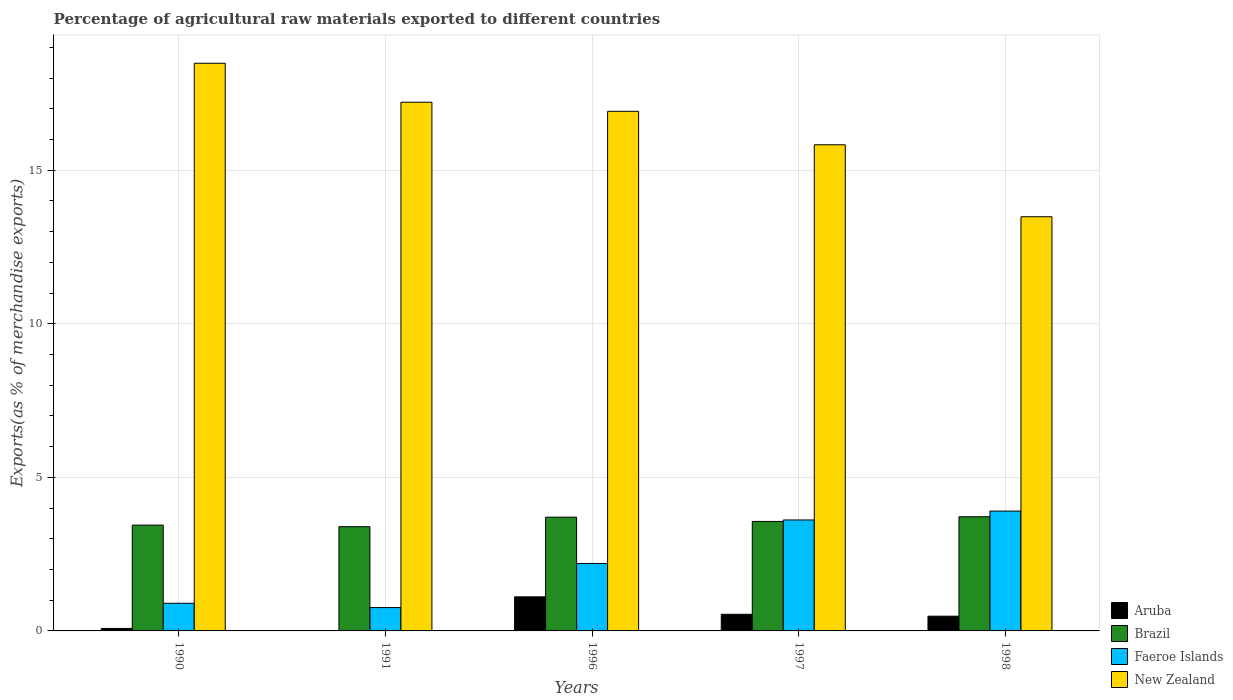Are the number of bars on each tick of the X-axis equal?
Your response must be concise. Yes. How many bars are there on the 4th tick from the left?
Provide a short and direct response. 4. What is the label of the 2nd group of bars from the left?
Provide a succinct answer. 1991. In how many cases, is the number of bars for a given year not equal to the number of legend labels?
Provide a succinct answer. 0. What is the percentage of exports to different countries in New Zealand in 1998?
Your response must be concise. 13.48. Across all years, what is the maximum percentage of exports to different countries in Aruba?
Keep it short and to the point. 1.11. Across all years, what is the minimum percentage of exports to different countries in Brazil?
Give a very brief answer. 3.39. In which year was the percentage of exports to different countries in Aruba minimum?
Give a very brief answer. 1991. What is the total percentage of exports to different countries in New Zealand in the graph?
Your response must be concise. 81.92. What is the difference between the percentage of exports to different countries in New Zealand in 1991 and that in 1998?
Offer a very short reply. 3.73. What is the difference between the percentage of exports to different countries in Faeroe Islands in 1997 and the percentage of exports to different countries in Brazil in 1991?
Make the answer very short. 0.22. What is the average percentage of exports to different countries in Faeroe Islands per year?
Provide a succinct answer. 2.27. In the year 1997, what is the difference between the percentage of exports to different countries in Aruba and percentage of exports to different countries in Brazil?
Provide a succinct answer. -3.02. In how many years, is the percentage of exports to different countries in New Zealand greater than 14 %?
Offer a very short reply. 4. What is the ratio of the percentage of exports to different countries in Aruba in 1991 to that in 1998?
Offer a terse response. 0.01. What is the difference between the highest and the second highest percentage of exports to different countries in Brazil?
Make the answer very short. 0.01. What is the difference between the highest and the lowest percentage of exports to different countries in New Zealand?
Give a very brief answer. 5. In how many years, is the percentage of exports to different countries in Brazil greater than the average percentage of exports to different countries in Brazil taken over all years?
Make the answer very short. 2. Is the sum of the percentage of exports to different countries in Faeroe Islands in 1991 and 1996 greater than the maximum percentage of exports to different countries in Aruba across all years?
Keep it short and to the point. Yes. Is it the case that in every year, the sum of the percentage of exports to different countries in Brazil and percentage of exports to different countries in Aruba is greater than the sum of percentage of exports to different countries in Faeroe Islands and percentage of exports to different countries in New Zealand?
Make the answer very short. No. What does the 2nd bar from the left in 1997 represents?
Offer a terse response. Brazil. What does the 4th bar from the right in 1991 represents?
Make the answer very short. Aruba. How many bars are there?
Your response must be concise. 20. Are all the bars in the graph horizontal?
Your response must be concise. No. How many years are there in the graph?
Keep it short and to the point. 5. Are the values on the major ticks of Y-axis written in scientific E-notation?
Keep it short and to the point. No. Does the graph contain any zero values?
Offer a very short reply. No. Where does the legend appear in the graph?
Provide a short and direct response. Bottom right. How many legend labels are there?
Offer a terse response. 4. What is the title of the graph?
Give a very brief answer. Percentage of agricultural raw materials exported to different countries. What is the label or title of the X-axis?
Offer a terse response. Years. What is the label or title of the Y-axis?
Make the answer very short. Exports(as % of merchandise exports). What is the Exports(as % of merchandise exports) in Aruba in 1990?
Your response must be concise. 0.08. What is the Exports(as % of merchandise exports) of Brazil in 1990?
Your answer should be compact. 3.44. What is the Exports(as % of merchandise exports) of Faeroe Islands in 1990?
Your answer should be compact. 0.9. What is the Exports(as % of merchandise exports) of New Zealand in 1990?
Provide a short and direct response. 18.48. What is the Exports(as % of merchandise exports) of Aruba in 1991?
Provide a succinct answer. 0. What is the Exports(as % of merchandise exports) in Brazil in 1991?
Provide a short and direct response. 3.39. What is the Exports(as % of merchandise exports) of Faeroe Islands in 1991?
Provide a short and direct response. 0.76. What is the Exports(as % of merchandise exports) in New Zealand in 1991?
Keep it short and to the point. 17.21. What is the Exports(as % of merchandise exports) in Aruba in 1996?
Ensure brevity in your answer.  1.11. What is the Exports(as % of merchandise exports) of Brazil in 1996?
Offer a terse response. 3.7. What is the Exports(as % of merchandise exports) of Faeroe Islands in 1996?
Offer a very short reply. 2.2. What is the Exports(as % of merchandise exports) in New Zealand in 1996?
Provide a short and direct response. 16.92. What is the Exports(as % of merchandise exports) in Aruba in 1997?
Your response must be concise. 0.54. What is the Exports(as % of merchandise exports) in Brazil in 1997?
Keep it short and to the point. 3.56. What is the Exports(as % of merchandise exports) of Faeroe Islands in 1997?
Make the answer very short. 3.61. What is the Exports(as % of merchandise exports) of New Zealand in 1997?
Give a very brief answer. 15.83. What is the Exports(as % of merchandise exports) in Aruba in 1998?
Your answer should be compact. 0.48. What is the Exports(as % of merchandise exports) in Brazil in 1998?
Your answer should be compact. 3.72. What is the Exports(as % of merchandise exports) of Faeroe Islands in 1998?
Keep it short and to the point. 3.9. What is the Exports(as % of merchandise exports) of New Zealand in 1998?
Provide a succinct answer. 13.48. Across all years, what is the maximum Exports(as % of merchandise exports) of Aruba?
Your answer should be compact. 1.11. Across all years, what is the maximum Exports(as % of merchandise exports) of Brazil?
Provide a succinct answer. 3.72. Across all years, what is the maximum Exports(as % of merchandise exports) in Faeroe Islands?
Make the answer very short. 3.9. Across all years, what is the maximum Exports(as % of merchandise exports) in New Zealand?
Your answer should be compact. 18.48. Across all years, what is the minimum Exports(as % of merchandise exports) in Aruba?
Offer a very short reply. 0. Across all years, what is the minimum Exports(as % of merchandise exports) in Brazil?
Offer a terse response. 3.39. Across all years, what is the minimum Exports(as % of merchandise exports) in Faeroe Islands?
Your answer should be very brief. 0.76. Across all years, what is the minimum Exports(as % of merchandise exports) in New Zealand?
Your response must be concise. 13.48. What is the total Exports(as % of merchandise exports) in Aruba in the graph?
Keep it short and to the point. 2.22. What is the total Exports(as % of merchandise exports) in Brazil in the graph?
Your answer should be compact. 17.82. What is the total Exports(as % of merchandise exports) of Faeroe Islands in the graph?
Ensure brevity in your answer.  11.37. What is the total Exports(as % of merchandise exports) in New Zealand in the graph?
Offer a terse response. 81.92. What is the difference between the Exports(as % of merchandise exports) of Aruba in 1990 and that in 1991?
Give a very brief answer. 0.08. What is the difference between the Exports(as % of merchandise exports) of Brazil in 1990 and that in 1991?
Offer a very short reply. 0.05. What is the difference between the Exports(as % of merchandise exports) in Faeroe Islands in 1990 and that in 1991?
Your response must be concise. 0.14. What is the difference between the Exports(as % of merchandise exports) of New Zealand in 1990 and that in 1991?
Your answer should be very brief. 1.27. What is the difference between the Exports(as % of merchandise exports) of Aruba in 1990 and that in 1996?
Your response must be concise. -1.03. What is the difference between the Exports(as % of merchandise exports) of Brazil in 1990 and that in 1996?
Give a very brief answer. -0.26. What is the difference between the Exports(as % of merchandise exports) of Faeroe Islands in 1990 and that in 1996?
Keep it short and to the point. -1.3. What is the difference between the Exports(as % of merchandise exports) in New Zealand in 1990 and that in 1996?
Ensure brevity in your answer.  1.56. What is the difference between the Exports(as % of merchandise exports) in Aruba in 1990 and that in 1997?
Your response must be concise. -0.46. What is the difference between the Exports(as % of merchandise exports) of Brazil in 1990 and that in 1997?
Your response must be concise. -0.12. What is the difference between the Exports(as % of merchandise exports) of Faeroe Islands in 1990 and that in 1997?
Give a very brief answer. -2.71. What is the difference between the Exports(as % of merchandise exports) in New Zealand in 1990 and that in 1997?
Make the answer very short. 2.65. What is the difference between the Exports(as % of merchandise exports) of Aruba in 1990 and that in 1998?
Give a very brief answer. -0.4. What is the difference between the Exports(as % of merchandise exports) in Brazil in 1990 and that in 1998?
Your response must be concise. -0.27. What is the difference between the Exports(as % of merchandise exports) in Faeroe Islands in 1990 and that in 1998?
Provide a short and direct response. -3. What is the difference between the Exports(as % of merchandise exports) in New Zealand in 1990 and that in 1998?
Ensure brevity in your answer.  5. What is the difference between the Exports(as % of merchandise exports) in Aruba in 1991 and that in 1996?
Make the answer very short. -1.11. What is the difference between the Exports(as % of merchandise exports) of Brazil in 1991 and that in 1996?
Provide a short and direct response. -0.31. What is the difference between the Exports(as % of merchandise exports) of Faeroe Islands in 1991 and that in 1996?
Give a very brief answer. -1.44. What is the difference between the Exports(as % of merchandise exports) in New Zealand in 1991 and that in 1996?
Ensure brevity in your answer.  0.3. What is the difference between the Exports(as % of merchandise exports) of Aruba in 1991 and that in 1997?
Ensure brevity in your answer.  -0.54. What is the difference between the Exports(as % of merchandise exports) in Brazil in 1991 and that in 1997?
Make the answer very short. -0.17. What is the difference between the Exports(as % of merchandise exports) of Faeroe Islands in 1991 and that in 1997?
Your response must be concise. -2.85. What is the difference between the Exports(as % of merchandise exports) of New Zealand in 1991 and that in 1997?
Your response must be concise. 1.39. What is the difference between the Exports(as % of merchandise exports) in Aruba in 1991 and that in 1998?
Provide a short and direct response. -0.48. What is the difference between the Exports(as % of merchandise exports) in Brazil in 1991 and that in 1998?
Offer a terse response. -0.32. What is the difference between the Exports(as % of merchandise exports) in Faeroe Islands in 1991 and that in 1998?
Ensure brevity in your answer.  -3.14. What is the difference between the Exports(as % of merchandise exports) in New Zealand in 1991 and that in 1998?
Provide a short and direct response. 3.73. What is the difference between the Exports(as % of merchandise exports) of Aruba in 1996 and that in 1997?
Ensure brevity in your answer.  0.57. What is the difference between the Exports(as % of merchandise exports) of Brazil in 1996 and that in 1997?
Ensure brevity in your answer.  0.14. What is the difference between the Exports(as % of merchandise exports) of Faeroe Islands in 1996 and that in 1997?
Your response must be concise. -1.42. What is the difference between the Exports(as % of merchandise exports) in New Zealand in 1996 and that in 1997?
Ensure brevity in your answer.  1.09. What is the difference between the Exports(as % of merchandise exports) in Aruba in 1996 and that in 1998?
Your answer should be very brief. 0.63. What is the difference between the Exports(as % of merchandise exports) of Brazil in 1996 and that in 1998?
Provide a short and direct response. -0.01. What is the difference between the Exports(as % of merchandise exports) of Faeroe Islands in 1996 and that in 1998?
Make the answer very short. -1.71. What is the difference between the Exports(as % of merchandise exports) of New Zealand in 1996 and that in 1998?
Make the answer very short. 3.43. What is the difference between the Exports(as % of merchandise exports) of Aruba in 1997 and that in 1998?
Your response must be concise. 0.06. What is the difference between the Exports(as % of merchandise exports) of Brazil in 1997 and that in 1998?
Your response must be concise. -0.15. What is the difference between the Exports(as % of merchandise exports) in Faeroe Islands in 1997 and that in 1998?
Offer a terse response. -0.29. What is the difference between the Exports(as % of merchandise exports) in New Zealand in 1997 and that in 1998?
Your response must be concise. 2.34. What is the difference between the Exports(as % of merchandise exports) of Aruba in 1990 and the Exports(as % of merchandise exports) of Brazil in 1991?
Provide a succinct answer. -3.31. What is the difference between the Exports(as % of merchandise exports) of Aruba in 1990 and the Exports(as % of merchandise exports) of Faeroe Islands in 1991?
Provide a short and direct response. -0.68. What is the difference between the Exports(as % of merchandise exports) of Aruba in 1990 and the Exports(as % of merchandise exports) of New Zealand in 1991?
Keep it short and to the point. -17.13. What is the difference between the Exports(as % of merchandise exports) in Brazil in 1990 and the Exports(as % of merchandise exports) in Faeroe Islands in 1991?
Offer a very short reply. 2.68. What is the difference between the Exports(as % of merchandise exports) of Brazil in 1990 and the Exports(as % of merchandise exports) of New Zealand in 1991?
Provide a short and direct response. -13.77. What is the difference between the Exports(as % of merchandise exports) in Faeroe Islands in 1990 and the Exports(as % of merchandise exports) in New Zealand in 1991?
Offer a terse response. -16.31. What is the difference between the Exports(as % of merchandise exports) in Aruba in 1990 and the Exports(as % of merchandise exports) in Brazil in 1996?
Your answer should be compact. -3.62. What is the difference between the Exports(as % of merchandise exports) in Aruba in 1990 and the Exports(as % of merchandise exports) in Faeroe Islands in 1996?
Provide a short and direct response. -2.11. What is the difference between the Exports(as % of merchandise exports) of Aruba in 1990 and the Exports(as % of merchandise exports) of New Zealand in 1996?
Your response must be concise. -16.84. What is the difference between the Exports(as % of merchandise exports) of Brazil in 1990 and the Exports(as % of merchandise exports) of Faeroe Islands in 1996?
Your response must be concise. 1.25. What is the difference between the Exports(as % of merchandise exports) in Brazil in 1990 and the Exports(as % of merchandise exports) in New Zealand in 1996?
Keep it short and to the point. -13.47. What is the difference between the Exports(as % of merchandise exports) of Faeroe Islands in 1990 and the Exports(as % of merchandise exports) of New Zealand in 1996?
Keep it short and to the point. -16.02. What is the difference between the Exports(as % of merchandise exports) of Aruba in 1990 and the Exports(as % of merchandise exports) of Brazil in 1997?
Your answer should be very brief. -3.48. What is the difference between the Exports(as % of merchandise exports) of Aruba in 1990 and the Exports(as % of merchandise exports) of Faeroe Islands in 1997?
Offer a very short reply. -3.53. What is the difference between the Exports(as % of merchandise exports) of Aruba in 1990 and the Exports(as % of merchandise exports) of New Zealand in 1997?
Provide a short and direct response. -15.75. What is the difference between the Exports(as % of merchandise exports) in Brazil in 1990 and the Exports(as % of merchandise exports) in Faeroe Islands in 1997?
Give a very brief answer. -0.17. What is the difference between the Exports(as % of merchandise exports) in Brazil in 1990 and the Exports(as % of merchandise exports) in New Zealand in 1997?
Ensure brevity in your answer.  -12.38. What is the difference between the Exports(as % of merchandise exports) in Faeroe Islands in 1990 and the Exports(as % of merchandise exports) in New Zealand in 1997?
Your answer should be compact. -14.93. What is the difference between the Exports(as % of merchandise exports) of Aruba in 1990 and the Exports(as % of merchandise exports) of Brazil in 1998?
Your answer should be compact. -3.64. What is the difference between the Exports(as % of merchandise exports) in Aruba in 1990 and the Exports(as % of merchandise exports) in Faeroe Islands in 1998?
Offer a terse response. -3.82. What is the difference between the Exports(as % of merchandise exports) in Aruba in 1990 and the Exports(as % of merchandise exports) in New Zealand in 1998?
Offer a terse response. -13.4. What is the difference between the Exports(as % of merchandise exports) of Brazil in 1990 and the Exports(as % of merchandise exports) of Faeroe Islands in 1998?
Make the answer very short. -0.46. What is the difference between the Exports(as % of merchandise exports) of Brazil in 1990 and the Exports(as % of merchandise exports) of New Zealand in 1998?
Your response must be concise. -10.04. What is the difference between the Exports(as % of merchandise exports) in Faeroe Islands in 1990 and the Exports(as % of merchandise exports) in New Zealand in 1998?
Your response must be concise. -12.58. What is the difference between the Exports(as % of merchandise exports) in Aruba in 1991 and the Exports(as % of merchandise exports) in Brazil in 1996?
Offer a very short reply. -3.7. What is the difference between the Exports(as % of merchandise exports) of Aruba in 1991 and the Exports(as % of merchandise exports) of Faeroe Islands in 1996?
Offer a very short reply. -2.19. What is the difference between the Exports(as % of merchandise exports) of Aruba in 1991 and the Exports(as % of merchandise exports) of New Zealand in 1996?
Keep it short and to the point. -16.91. What is the difference between the Exports(as % of merchandise exports) in Brazil in 1991 and the Exports(as % of merchandise exports) in Faeroe Islands in 1996?
Your answer should be very brief. 1.2. What is the difference between the Exports(as % of merchandise exports) in Brazil in 1991 and the Exports(as % of merchandise exports) in New Zealand in 1996?
Offer a terse response. -13.52. What is the difference between the Exports(as % of merchandise exports) in Faeroe Islands in 1991 and the Exports(as % of merchandise exports) in New Zealand in 1996?
Provide a succinct answer. -16.16. What is the difference between the Exports(as % of merchandise exports) in Aruba in 1991 and the Exports(as % of merchandise exports) in Brazil in 1997?
Your answer should be compact. -3.56. What is the difference between the Exports(as % of merchandise exports) of Aruba in 1991 and the Exports(as % of merchandise exports) of Faeroe Islands in 1997?
Your response must be concise. -3.61. What is the difference between the Exports(as % of merchandise exports) of Aruba in 1991 and the Exports(as % of merchandise exports) of New Zealand in 1997?
Your answer should be compact. -15.82. What is the difference between the Exports(as % of merchandise exports) in Brazil in 1991 and the Exports(as % of merchandise exports) in Faeroe Islands in 1997?
Offer a very short reply. -0.22. What is the difference between the Exports(as % of merchandise exports) in Brazil in 1991 and the Exports(as % of merchandise exports) in New Zealand in 1997?
Provide a short and direct response. -12.43. What is the difference between the Exports(as % of merchandise exports) of Faeroe Islands in 1991 and the Exports(as % of merchandise exports) of New Zealand in 1997?
Offer a very short reply. -15.07. What is the difference between the Exports(as % of merchandise exports) in Aruba in 1991 and the Exports(as % of merchandise exports) in Brazil in 1998?
Make the answer very short. -3.71. What is the difference between the Exports(as % of merchandise exports) in Aruba in 1991 and the Exports(as % of merchandise exports) in Faeroe Islands in 1998?
Provide a short and direct response. -3.9. What is the difference between the Exports(as % of merchandise exports) in Aruba in 1991 and the Exports(as % of merchandise exports) in New Zealand in 1998?
Your answer should be compact. -13.48. What is the difference between the Exports(as % of merchandise exports) in Brazil in 1991 and the Exports(as % of merchandise exports) in Faeroe Islands in 1998?
Offer a terse response. -0.51. What is the difference between the Exports(as % of merchandise exports) of Brazil in 1991 and the Exports(as % of merchandise exports) of New Zealand in 1998?
Provide a succinct answer. -10.09. What is the difference between the Exports(as % of merchandise exports) of Faeroe Islands in 1991 and the Exports(as % of merchandise exports) of New Zealand in 1998?
Keep it short and to the point. -12.72. What is the difference between the Exports(as % of merchandise exports) in Aruba in 1996 and the Exports(as % of merchandise exports) in Brazil in 1997?
Make the answer very short. -2.45. What is the difference between the Exports(as % of merchandise exports) of Aruba in 1996 and the Exports(as % of merchandise exports) of Faeroe Islands in 1997?
Offer a terse response. -2.5. What is the difference between the Exports(as % of merchandise exports) in Aruba in 1996 and the Exports(as % of merchandise exports) in New Zealand in 1997?
Keep it short and to the point. -14.72. What is the difference between the Exports(as % of merchandise exports) in Brazil in 1996 and the Exports(as % of merchandise exports) in Faeroe Islands in 1997?
Give a very brief answer. 0.09. What is the difference between the Exports(as % of merchandise exports) in Brazil in 1996 and the Exports(as % of merchandise exports) in New Zealand in 1997?
Provide a succinct answer. -12.12. What is the difference between the Exports(as % of merchandise exports) of Faeroe Islands in 1996 and the Exports(as % of merchandise exports) of New Zealand in 1997?
Make the answer very short. -13.63. What is the difference between the Exports(as % of merchandise exports) in Aruba in 1996 and the Exports(as % of merchandise exports) in Brazil in 1998?
Ensure brevity in your answer.  -2.61. What is the difference between the Exports(as % of merchandise exports) in Aruba in 1996 and the Exports(as % of merchandise exports) in Faeroe Islands in 1998?
Give a very brief answer. -2.79. What is the difference between the Exports(as % of merchandise exports) in Aruba in 1996 and the Exports(as % of merchandise exports) in New Zealand in 1998?
Keep it short and to the point. -12.37. What is the difference between the Exports(as % of merchandise exports) of Brazil in 1996 and the Exports(as % of merchandise exports) of Faeroe Islands in 1998?
Offer a very short reply. -0.2. What is the difference between the Exports(as % of merchandise exports) of Brazil in 1996 and the Exports(as % of merchandise exports) of New Zealand in 1998?
Provide a short and direct response. -9.78. What is the difference between the Exports(as % of merchandise exports) of Faeroe Islands in 1996 and the Exports(as % of merchandise exports) of New Zealand in 1998?
Offer a very short reply. -11.29. What is the difference between the Exports(as % of merchandise exports) in Aruba in 1997 and the Exports(as % of merchandise exports) in Brazil in 1998?
Offer a very short reply. -3.18. What is the difference between the Exports(as % of merchandise exports) of Aruba in 1997 and the Exports(as % of merchandise exports) of Faeroe Islands in 1998?
Provide a succinct answer. -3.36. What is the difference between the Exports(as % of merchandise exports) of Aruba in 1997 and the Exports(as % of merchandise exports) of New Zealand in 1998?
Your answer should be compact. -12.94. What is the difference between the Exports(as % of merchandise exports) in Brazil in 1997 and the Exports(as % of merchandise exports) in Faeroe Islands in 1998?
Offer a very short reply. -0.34. What is the difference between the Exports(as % of merchandise exports) of Brazil in 1997 and the Exports(as % of merchandise exports) of New Zealand in 1998?
Provide a short and direct response. -9.92. What is the difference between the Exports(as % of merchandise exports) in Faeroe Islands in 1997 and the Exports(as % of merchandise exports) in New Zealand in 1998?
Your answer should be compact. -9.87. What is the average Exports(as % of merchandise exports) of Aruba per year?
Offer a terse response. 0.44. What is the average Exports(as % of merchandise exports) of Brazil per year?
Ensure brevity in your answer.  3.56. What is the average Exports(as % of merchandise exports) of Faeroe Islands per year?
Provide a short and direct response. 2.27. What is the average Exports(as % of merchandise exports) of New Zealand per year?
Your answer should be very brief. 16.38. In the year 1990, what is the difference between the Exports(as % of merchandise exports) in Aruba and Exports(as % of merchandise exports) in Brazil?
Ensure brevity in your answer.  -3.36. In the year 1990, what is the difference between the Exports(as % of merchandise exports) of Aruba and Exports(as % of merchandise exports) of Faeroe Islands?
Offer a very short reply. -0.82. In the year 1990, what is the difference between the Exports(as % of merchandise exports) in Aruba and Exports(as % of merchandise exports) in New Zealand?
Your answer should be very brief. -18.4. In the year 1990, what is the difference between the Exports(as % of merchandise exports) of Brazil and Exports(as % of merchandise exports) of Faeroe Islands?
Your response must be concise. 2.54. In the year 1990, what is the difference between the Exports(as % of merchandise exports) of Brazil and Exports(as % of merchandise exports) of New Zealand?
Your response must be concise. -15.04. In the year 1990, what is the difference between the Exports(as % of merchandise exports) in Faeroe Islands and Exports(as % of merchandise exports) in New Zealand?
Your answer should be very brief. -17.58. In the year 1991, what is the difference between the Exports(as % of merchandise exports) in Aruba and Exports(as % of merchandise exports) in Brazil?
Provide a succinct answer. -3.39. In the year 1991, what is the difference between the Exports(as % of merchandise exports) in Aruba and Exports(as % of merchandise exports) in Faeroe Islands?
Your answer should be very brief. -0.76. In the year 1991, what is the difference between the Exports(as % of merchandise exports) of Aruba and Exports(as % of merchandise exports) of New Zealand?
Provide a short and direct response. -17.21. In the year 1991, what is the difference between the Exports(as % of merchandise exports) of Brazil and Exports(as % of merchandise exports) of Faeroe Islands?
Make the answer very short. 2.63. In the year 1991, what is the difference between the Exports(as % of merchandise exports) of Brazil and Exports(as % of merchandise exports) of New Zealand?
Give a very brief answer. -13.82. In the year 1991, what is the difference between the Exports(as % of merchandise exports) of Faeroe Islands and Exports(as % of merchandise exports) of New Zealand?
Make the answer very short. -16.45. In the year 1996, what is the difference between the Exports(as % of merchandise exports) of Aruba and Exports(as % of merchandise exports) of Brazil?
Offer a terse response. -2.59. In the year 1996, what is the difference between the Exports(as % of merchandise exports) of Aruba and Exports(as % of merchandise exports) of Faeroe Islands?
Provide a succinct answer. -1.09. In the year 1996, what is the difference between the Exports(as % of merchandise exports) in Aruba and Exports(as % of merchandise exports) in New Zealand?
Give a very brief answer. -15.81. In the year 1996, what is the difference between the Exports(as % of merchandise exports) of Brazil and Exports(as % of merchandise exports) of Faeroe Islands?
Offer a terse response. 1.51. In the year 1996, what is the difference between the Exports(as % of merchandise exports) in Brazil and Exports(as % of merchandise exports) in New Zealand?
Ensure brevity in your answer.  -13.21. In the year 1996, what is the difference between the Exports(as % of merchandise exports) in Faeroe Islands and Exports(as % of merchandise exports) in New Zealand?
Provide a succinct answer. -14.72. In the year 1997, what is the difference between the Exports(as % of merchandise exports) of Aruba and Exports(as % of merchandise exports) of Brazil?
Give a very brief answer. -3.02. In the year 1997, what is the difference between the Exports(as % of merchandise exports) of Aruba and Exports(as % of merchandise exports) of Faeroe Islands?
Your response must be concise. -3.07. In the year 1997, what is the difference between the Exports(as % of merchandise exports) of Aruba and Exports(as % of merchandise exports) of New Zealand?
Your answer should be compact. -15.28. In the year 1997, what is the difference between the Exports(as % of merchandise exports) of Brazil and Exports(as % of merchandise exports) of Faeroe Islands?
Ensure brevity in your answer.  -0.05. In the year 1997, what is the difference between the Exports(as % of merchandise exports) in Brazil and Exports(as % of merchandise exports) in New Zealand?
Give a very brief answer. -12.26. In the year 1997, what is the difference between the Exports(as % of merchandise exports) in Faeroe Islands and Exports(as % of merchandise exports) in New Zealand?
Ensure brevity in your answer.  -12.21. In the year 1998, what is the difference between the Exports(as % of merchandise exports) of Aruba and Exports(as % of merchandise exports) of Brazil?
Your answer should be very brief. -3.24. In the year 1998, what is the difference between the Exports(as % of merchandise exports) of Aruba and Exports(as % of merchandise exports) of Faeroe Islands?
Make the answer very short. -3.42. In the year 1998, what is the difference between the Exports(as % of merchandise exports) of Aruba and Exports(as % of merchandise exports) of New Zealand?
Make the answer very short. -13. In the year 1998, what is the difference between the Exports(as % of merchandise exports) in Brazil and Exports(as % of merchandise exports) in Faeroe Islands?
Ensure brevity in your answer.  -0.19. In the year 1998, what is the difference between the Exports(as % of merchandise exports) in Brazil and Exports(as % of merchandise exports) in New Zealand?
Give a very brief answer. -9.77. In the year 1998, what is the difference between the Exports(as % of merchandise exports) of Faeroe Islands and Exports(as % of merchandise exports) of New Zealand?
Offer a terse response. -9.58. What is the ratio of the Exports(as % of merchandise exports) of Aruba in 1990 to that in 1991?
Provide a short and direct response. 18.9. What is the ratio of the Exports(as % of merchandise exports) of Brazil in 1990 to that in 1991?
Provide a succinct answer. 1.01. What is the ratio of the Exports(as % of merchandise exports) of Faeroe Islands in 1990 to that in 1991?
Give a very brief answer. 1.18. What is the ratio of the Exports(as % of merchandise exports) in New Zealand in 1990 to that in 1991?
Your answer should be very brief. 1.07. What is the ratio of the Exports(as % of merchandise exports) in Aruba in 1990 to that in 1996?
Your answer should be compact. 0.07. What is the ratio of the Exports(as % of merchandise exports) of Faeroe Islands in 1990 to that in 1996?
Give a very brief answer. 0.41. What is the ratio of the Exports(as % of merchandise exports) in New Zealand in 1990 to that in 1996?
Ensure brevity in your answer.  1.09. What is the ratio of the Exports(as % of merchandise exports) in Aruba in 1990 to that in 1997?
Provide a succinct answer. 0.15. What is the ratio of the Exports(as % of merchandise exports) in Brazil in 1990 to that in 1997?
Keep it short and to the point. 0.97. What is the ratio of the Exports(as % of merchandise exports) in Faeroe Islands in 1990 to that in 1997?
Give a very brief answer. 0.25. What is the ratio of the Exports(as % of merchandise exports) of New Zealand in 1990 to that in 1997?
Provide a short and direct response. 1.17. What is the ratio of the Exports(as % of merchandise exports) of Aruba in 1990 to that in 1998?
Provide a short and direct response. 0.17. What is the ratio of the Exports(as % of merchandise exports) of Brazil in 1990 to that in 1998?
Ensure brevity in your answer.  0.93. What is the ratio of the Exports(as % of merchandise exports) in Faeroe Islands in 1990 to that in 1998?
Offer a terse response. 0.23. What is the ratio of the Exports(as % of merchandise exports) of New Zealand in 1990 to that in 1998?
Offer a terse response. 1.37. What is the ratio of the Exports(as % of merchandise exports) of Aruba in 1991 to that in 1996?
Make the answer very short. 0. What is the ratio of the Exports(as % of merchandise exports) of Brazil in 1991 to that in 1996?
Ensure brevity in your answer.  0.92. What is the ratio of the Exports(as % of merchandise exports) of Faeroe Islands in 1991 to that in 1996?
Keep it short and to the point. 0.35. What is the ratio of the Exports(as % of merchandise exports) in New Zealand in 1991 to that in 1996?
Keep it short and to the point. 1.02. What is the ratio of the Exports(as % of merchandise exports) of Aruba in 1991 to that in 1997?
Offer a very short reply. 0.01. What is the ratio of the Exports(as % of merchandise exports) of Brazil in 1991 to that in 1997?
Ensure brevity in your answer.  0.95. What is the ratio of the Exports(as % of merchandise exports) in Faeroe Islands in 1991 to that in 1997?
Provide a short and direct response. 0.21. What is the ratio of the Exports(as % of merchandise exports) in New Zealand in 1991 to that in 1997?
Make the answer very short. 1.09. What is the ratio of the Exports(as % of merchandise exports) in Aruba in 1991 to that in 1998?
Your response must be concise. 0.01. What is the ratio of the Exports(as % of merchandise exports) in Brazil in 1991 to that in 1998?
Make the answer very short. 0.91. What is the ratio of the Exports(as % of merchandise exports) in Faeroe Islands in 1991 to that in 1998?
Provide a succinct answer. 0.19. What is the ratio of the Exports(as % of merchandise exports) in New Zealand in 1991 to that in 1998?
Keep it short and to the point. 1.28. What is the ratio of the Exports(as % of merchandise exports) of Aruba in 1996 to that in 1997?
Keep it short and to the point. 2.05. What is the ratio of the Exports(as % of merchandise exports) in Brazil in 1996 to that in 1997?
Provide a succinct answer. 1.04. What is the ratio of the Exports(as % of merchandise exports) in Faeroe Islands in 1996 to that in 1997?
Make the answer very short. 0.61. What is the ratio of the Exports(as % of merchandise exports) of New Zealand in 1996 to that in 1997?
Your response must be concise. 1.07. What is the ratio of the Exports(as % of merchandise exports) in Aruba in 1996 to that in 1998?
Your response must be concise. 2.31. What is the ratio of the Exports(as % of merchandise exports) of Faeroe Islands in 1996 to that in 1998?
Your response must be concise. 0.56. What is the ratio of the Exports(as % of merchandise exports) in New Zealand in 1996 to that in 1998?
Offer a terse response. 1.25. What is the ratio of the Exports(as % of merchandise exports) in Aruba in 1997 to that in 1998?
Offer a very short reply. 1.13. What is the ratio of the Exports(as % of merchandise exports) of Brazil in 1997 to that in 1998?
Your answer should be compact. 0.96. What is the ratio of the Exports(as % of merchandise exports) in Faeroe Islands in 1997 to that in 1998?
Provide a short and direct response. 0.93. What is the ratio of the Exports(as % of merchandise exports) in New Zealand in 1997 to that in 1998?
Your answer should be very brief. 1.17. What is the difference between the highest and the second highest Exports(as % of merchandise exports) of Aruba?
Your response must be concise. 0.57. What is the difference between the highest and the second highest Exports(as % of merchandise exports) in Brazil?
Keep it short and to the point. 0.01. What is the difference between the highest and the second highest Exports(as % of merchandise exports) in Faeroe Islands?
Offer a very short reply. 0.29. What is the difference between the highest and the second highest Exports(as % of merchandise exports) of New Zealand?
Provide a short and direct response. 1.27. What is the difference between the highest and the lowest Exports(as % of merchandise exports) of Aruba?
Make the answer very short. 1.11. What is the difference between the highest and the lowest Exports(as % of merchandise exports) of Brazil?
Your response must be concise. 0.32. What is the difference between the highest and the lowest Exports(as % of merchandise exports) of Faeroe Islands?
Offer a very short reply. 3.14. What is the difference between the highest and the lowest Exports(as % of merchandise exports) in New Zealand?
Your answer should be compact. 5. 